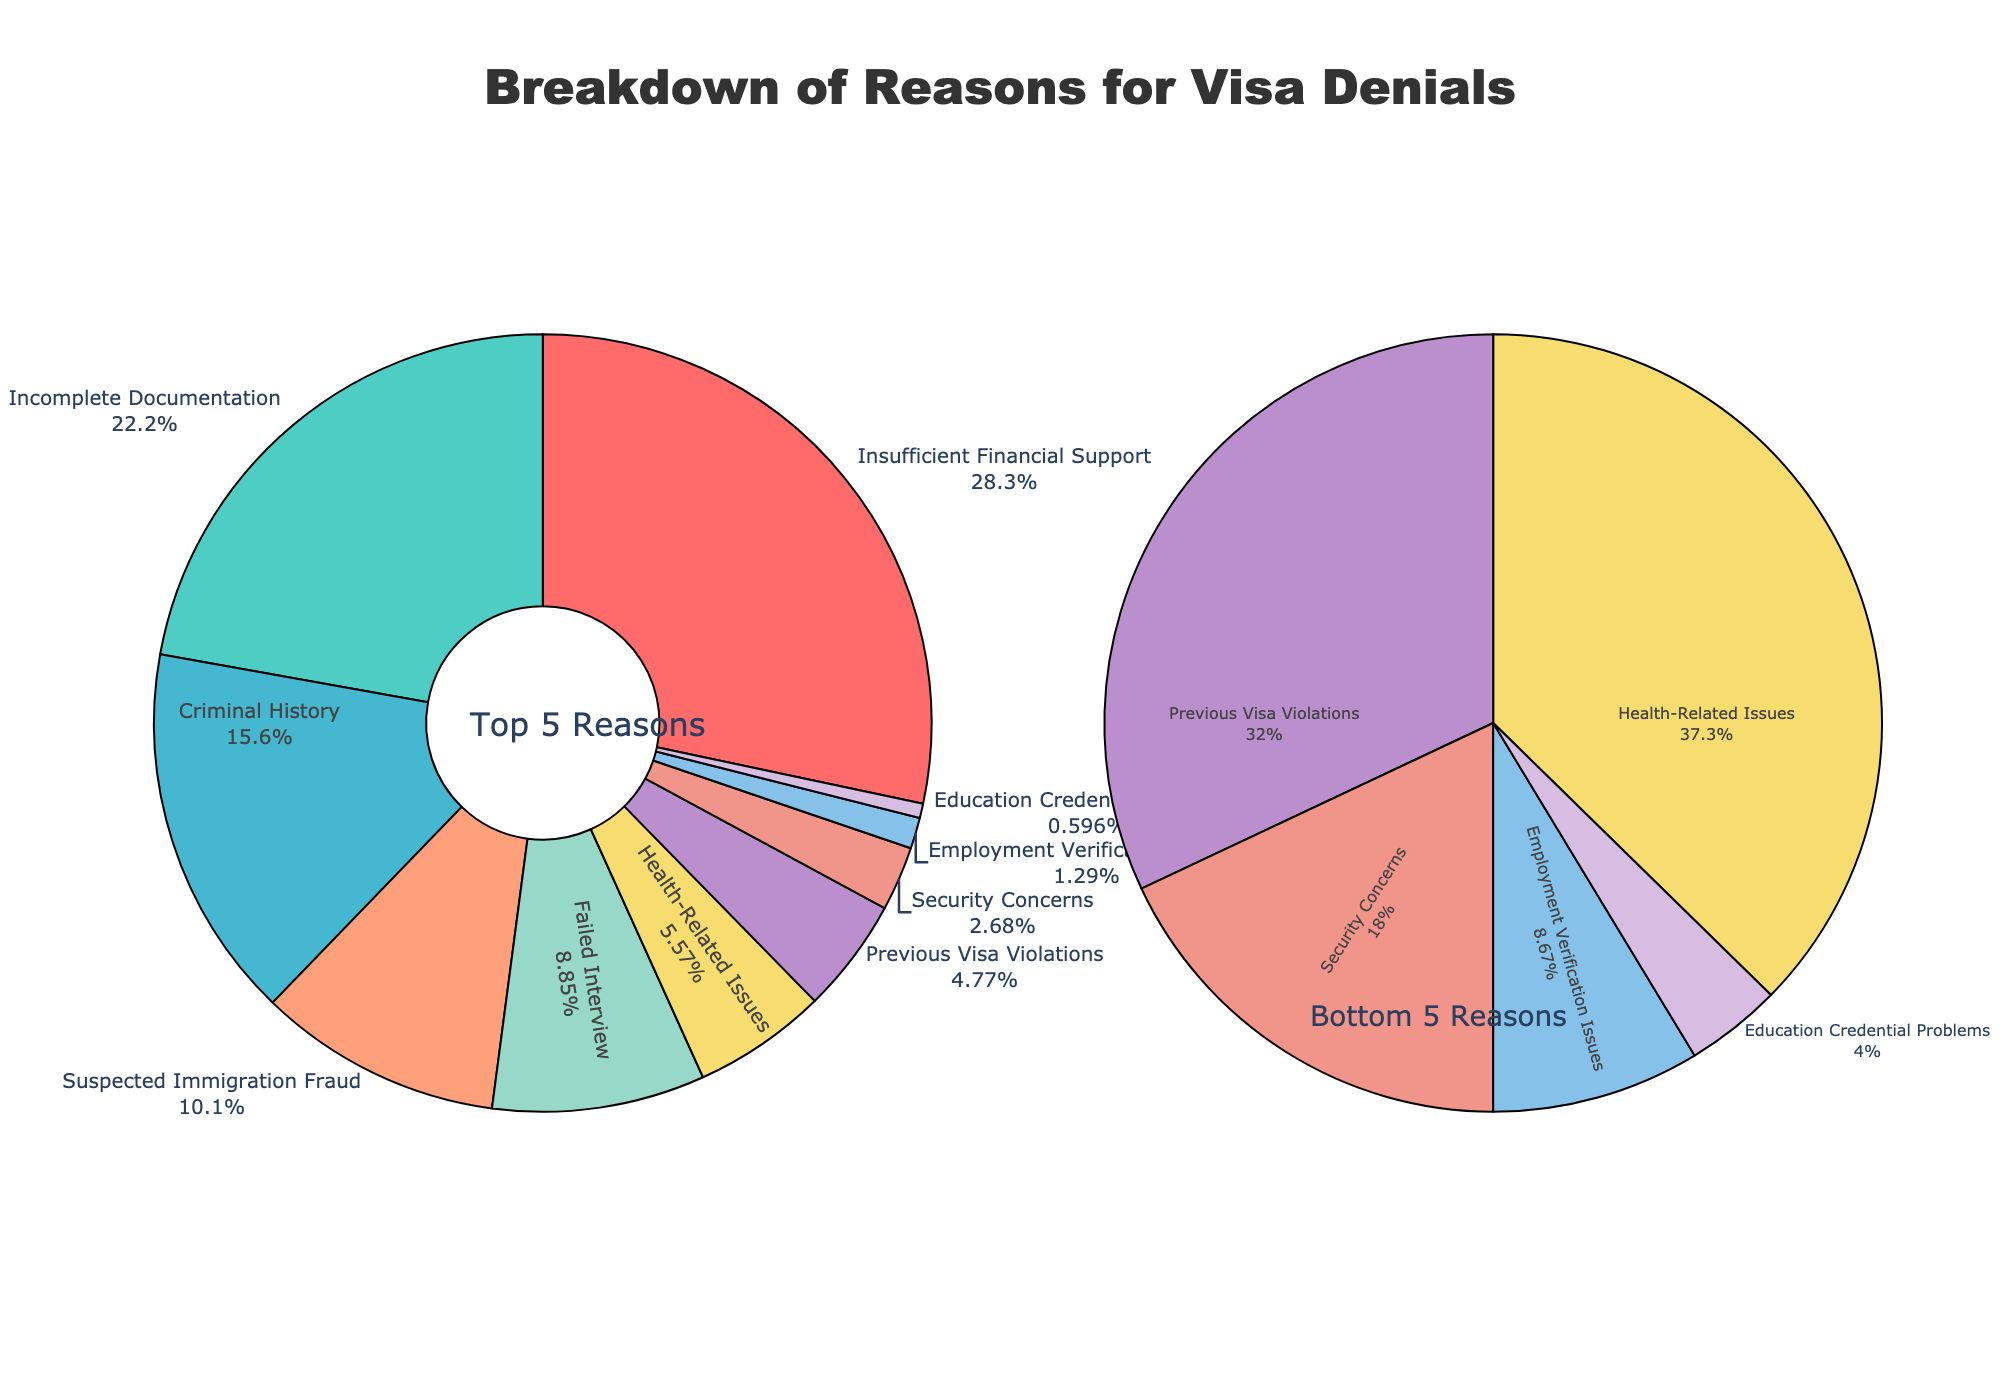Which reason is the most common for visa denials? The largest segment of the main pie chart is labeled "Insufficient Financial Support," which has the highest percentage.
Answer: Insufficient Financial Support What is the combined percentage of "Insufficient Financial Support" and "Incomplete Documentation"? According to the pie chart, "Insufficient Financial Support" is 28.5% and "Incomplete Documentation" is 22.3%. The sum is 28.5 + 22.3 = 50.8%.
Answer: 50.8% Which reason has a higher percentage: "Criminal History" or "Failed Interview"? From the main pie chart, "Criminal History" has a percentage of 15.7%, while "Failed Interview" has a percentage of 8.9%. Therefore, "Criminal History" is higher.
Answer: Criminal History How does the percentage of "Suspected Immigration Fraud" compare to "Previous Visa Violations"? The main pie chart shows "Suspected Immigration Fraud" at 10.2% and "Previous Visa Violations" at 4.8%. "Suspected Immigration Fraud" is significantly higher.
Answer: Suspected Immigration Fraud Which reason has the smallest percentage in the bottom 5 reasons pie chart? The smaller pie chart for the bottom 5 reasons shows the reason "Education Credential Problems" with the smallest percentage of 0.6%.
Answer: Education Credential Problems What is the total percentage of the bottom 5 reasons combined? The percentages for the bottom 5 reasons are: Health-Related Issues (5.6%), Previous Visa Violations (4.8%), Security Concerns (2.7%), Employment Verification Issues (1.3%), and Education Credential Problems (0.6%). The total is 5.6 + 4.8 + 2.7 + 1.3 + 0.6 = 15%.
Answer: 15% Is the percentage of "Health-Related Issues" or the combined percentage of "Security Concerns" and "Education Credential Problems" larger? The main pie chart shows "Health-Related Issues" at 5.6%. The combined percentage of "Security Concerns" (2.7%) and "Education Credential Problems" (0.6%) is 2.7 + 0.6 = 3.3%. Thus, "Health-Related Issues" is larger.
Answer: Health-Related Issues How much more common is "Failed Interview" than "Employment Verification Issues"? "Failed Interview" is 8.9% and "Employment Verification Issues" is 1.3%. The difference is 8.9 - 1.3 = 7.6%.
Answer: 7.6% What is the average percentage of the top 5 reasons? The top 5 reasons have percentages of: Insufficient Financial Support (28.5%), Incomplete Documentation (22.3%), Criminal History (15.7%), Suspected Immigration Fraud (10.2%), and Failed Interview (8.9%). The average is (28.5 + 22.3 + 15.7 + 10.2 + 8.9) / 5 = 17.12%.
Answer: 17.12% Which reasons are depicted with similar colors? The main pie chart shows "Insufficient Financial Support" in red and "Failed Interview" in a shade of pinkish-red. The smaller pie chart shows "Employment Verification Issues" and "Education Credential Problems" in shades of purple.
Answer: Insufficient Financial Support, Failed Interview; Employment Verification Issues, Education Credential Problems 